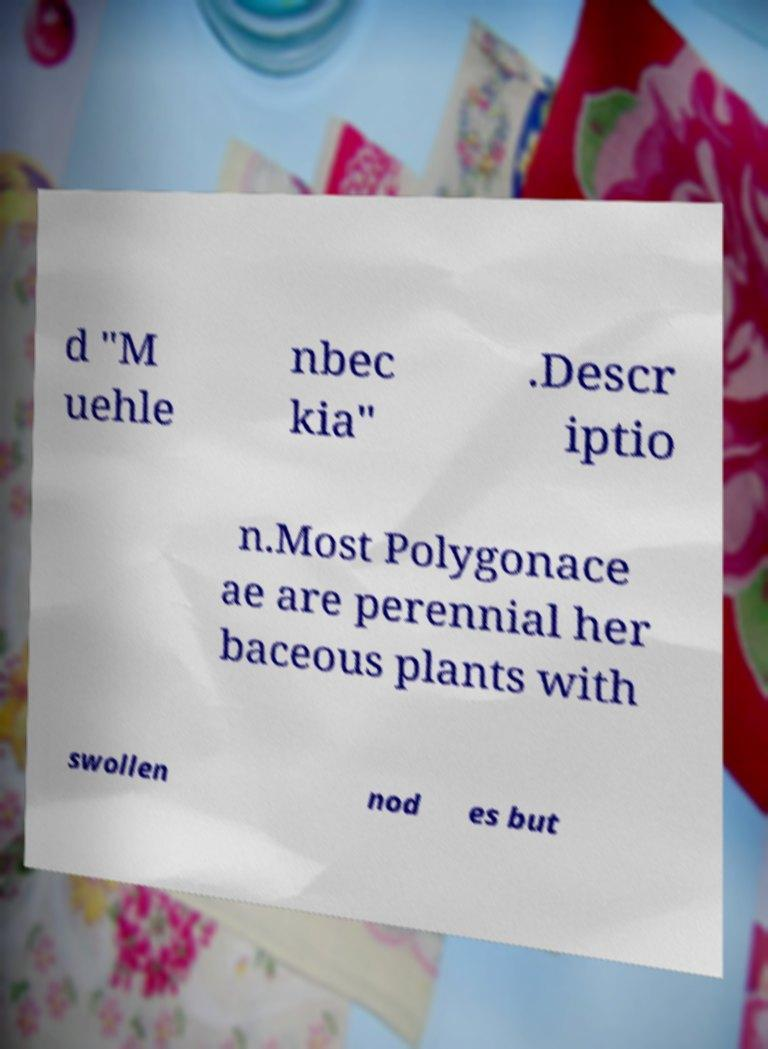Could you assist in decoding the text presented in this image and type it out clearly? d "M uehle nbec kia" .Descr iptio n.Most Polygonace ae are perennial her baceous plants with swollen nod es but 